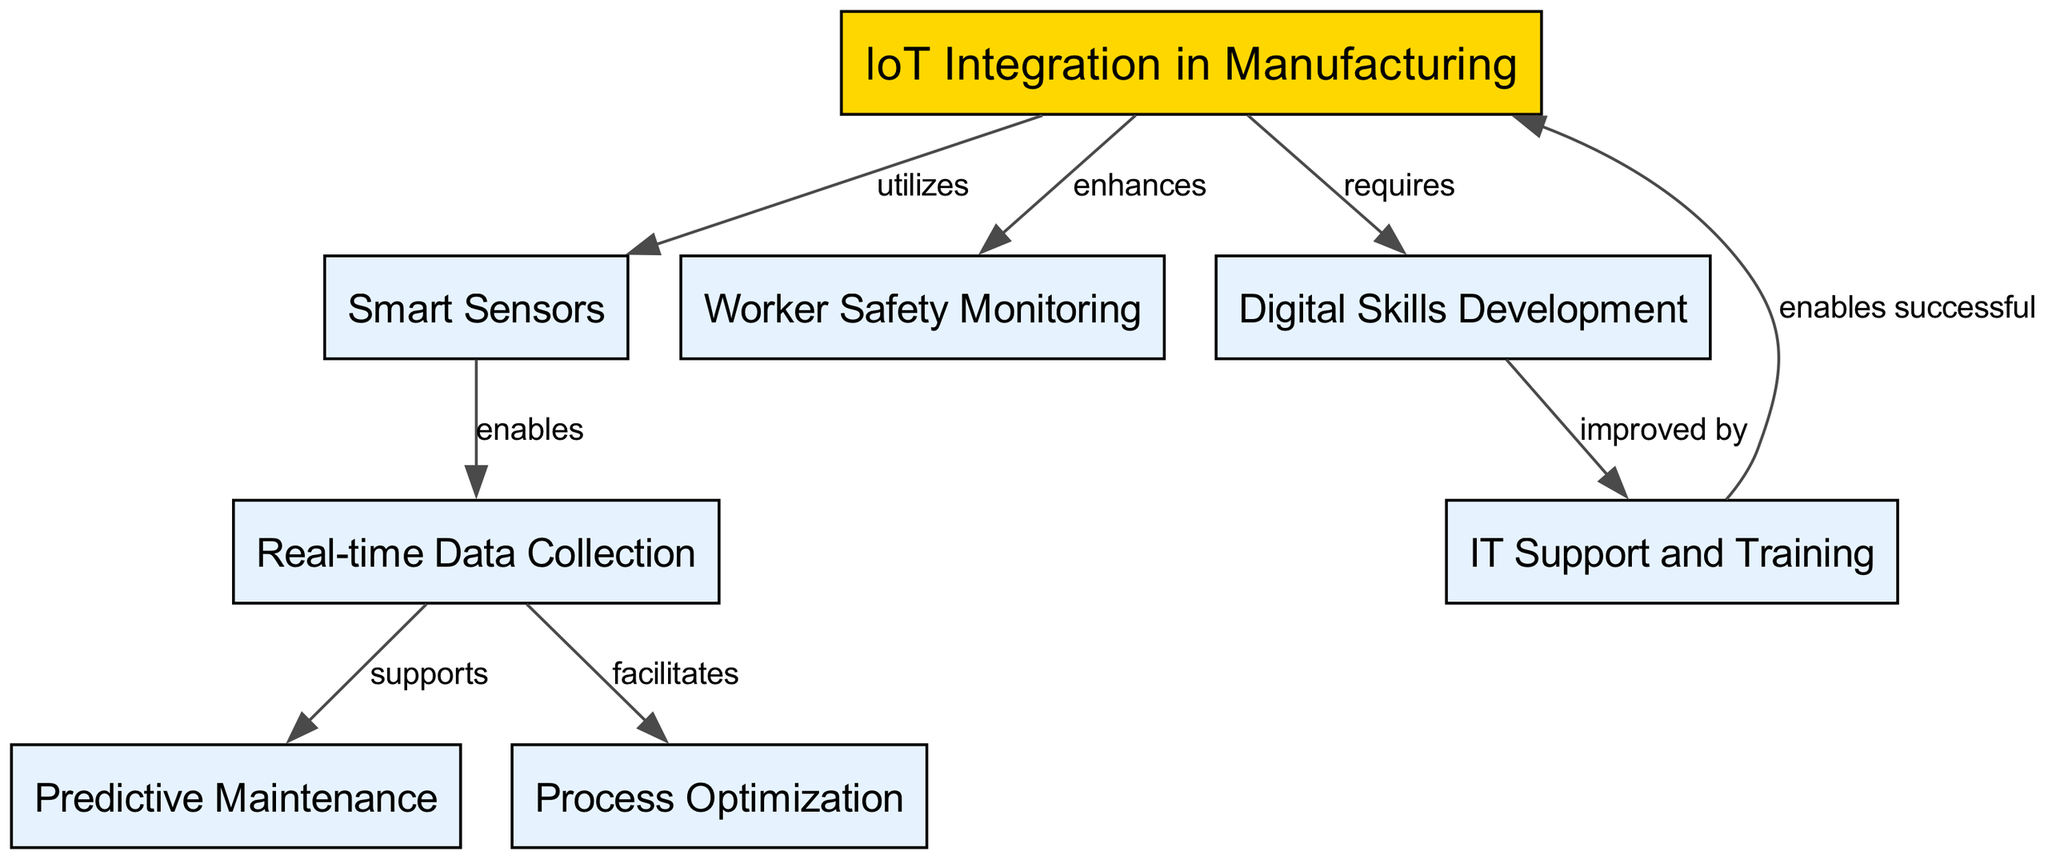What is the main concept represented in the diagram? The diagram's main concept is identified as "IoT Integration in Manufacturing," which is prominently displayed at the top as the central node.
Answer: IoT Integration in Manufacturing How many nodes are present in the diagram? By counting each unique labeled element in the diagram, we identify a total of eight distinct nodes representing various aspects of IoT integration.
Answer: 8 What relationship exists between Smart Sensors and Data Collection? The diagram indicates that Smart Sensors "enables" Data Collection, establishing a direct relationship that shows the functional dependency of data capture on smart sensors.
Answer: enables Which aspect of IoT integration enhances worker safety? The diagram directly states that IoT Integration "enhances" Worker Safety, indicating that the implementation of IoT contributes positively to the safety of workers in the manufacturing environment.
Answer: enhances What does Data Collection support in the IoT Integration process? The diagram shows that Data Collection supports Predictive Maintenance, indicating that the real-time data obtained through IoT devices is used for proactive maintenance activities.
Answer: Predictive Maintenance How does Digital Skills impact IT Support? Digital Skills development is "improved by" IT Support, suggesting that effective IT assistance and training lead to better digital skills among workers, creating a mutually beneficial relationship.
Answer: improved by What process is facilitated by Data Collection? From the diagram, it is clear that Data Collection facilitates Process Optimization, indicating that collecting data in real time helps in improving manufacturing processes.
Answer: Process Optimization In what way does IT Support contribute to IoT Integration? The diagram indicates that IT Support "enables successful" IoT Integration, highlighting the importance of IT assistance in achieving effective integration of IoT technologies in manufacturing.
Answer: enables successful What is required for IoT Integration to take place? The diagram defines that IoT Integration requires Digital Skills, showcasing the need for workers to possess certain digital competencies to successfully implement IoT solutions.
Answer: requires 